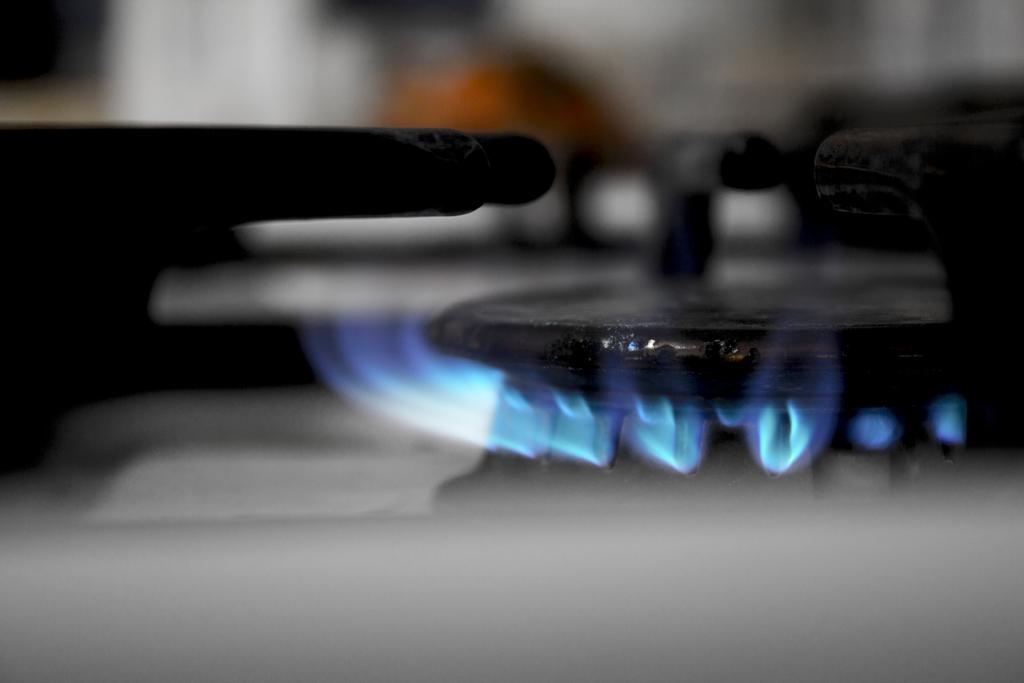What can be seen in the image that is used for cooking or heating? There is a burner in the image. What is present in the image that indicates heat or fire? There is fire in the image. What type of cemetery can be seen in the image? There is no cemetery present in the image. What is the current status of the fire in the image? The image does not provide information about the current status of the fire, only that it is present. 